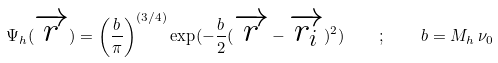Convert formula to latex. <formula><loc_0><loc_0><loc_500><loc_500>\Psi _ { h } ( \overrightarrow { r } ) = \left ( { \frac { b } { \pi } } \right ) ^ { ( 3 / 4 ) } \exp ( - \frac { b } { 2 } ( \overrightarrow { r } - \overrightarrow { { r } _ { i } } ) ^ { 2 } ) \quad ; \quad b = M _ { h } \, \nu _ { 0 }</formula> 